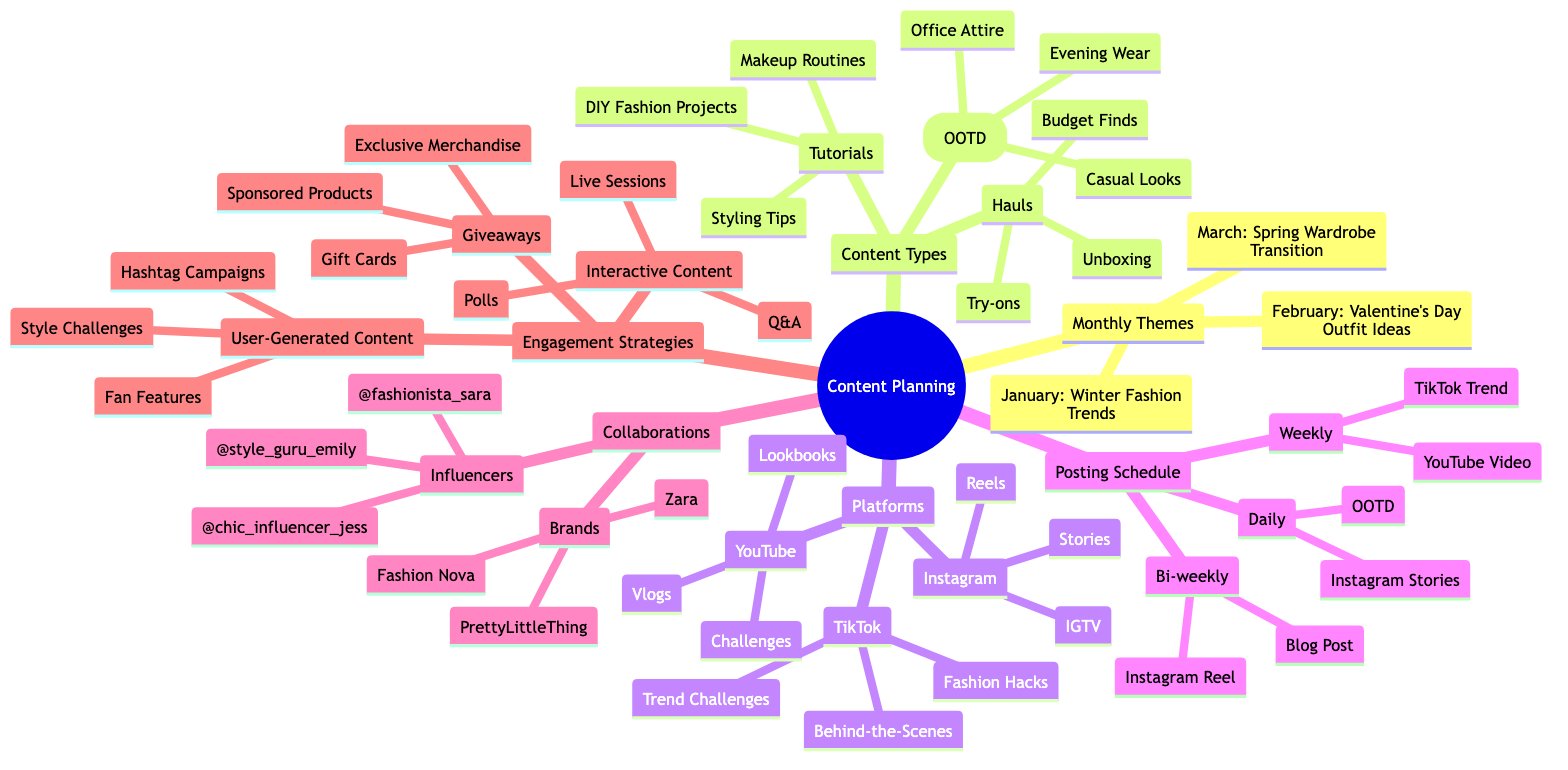What's the theme for March? The mind map indicates that the theme for March under Monthly Themes is "Spring Wardrobe Transition." This can be found directly under the "March" node.
Answer: Spring Wardrobe Transition How many Content Types are listed? The diagram shows three main categories under Content Types: "Outfit of the Day (OOTD)," "Hauls," and "Tutorials." Thus, there are three distinct Content Types.
Answer: 3 What are the platforms mentioned? The platforms listed in the mind map include Instagram, YouTube, and TikTok. This information is found under the main node "Platforms."
Answer: Instagram, YouTube, TikTok What content type includes 'Evening Wear'? "Evening Wear" is categorized under the "Outfit of the Day (OOTD)" content type. By referencing the specific node, you can identify this inclusion.
Answer: Outfit of the Day (OOTD) Which brands are collaborations with? The collaboration section lists "Fashion Nova," "PrettyLittleThing," and "Zara" as the brands. This information can be found under the "Collaborations" node, specifically in the "Brands" sub-node.
Answer: Fashion Nova, PrettyLittleThing, Zara What is the posting frequency for Instagram Stories? The diagram notes that "Instagram Stories" are part of the daily posting schedule. This is indicated under the "Daily" sub-node which connects back to the Posting Schedule category.
Answer: Daily Which engagement strategy involves live sessions? "Live Sessions" are categorized under "Interactive Content" as part of the Engagement Strategies node. By checking the Engagement Strategies section, you can locate this sub-category.
Answer: Interactive Content How many types of user-generated content are mentioned? The User-Generated Content section counts three types: "Hashtag Campaigns," "Fan Features," and "Style Challenges," which can all be found under the "User-Generated Content" sub-node.
Answer: 3 